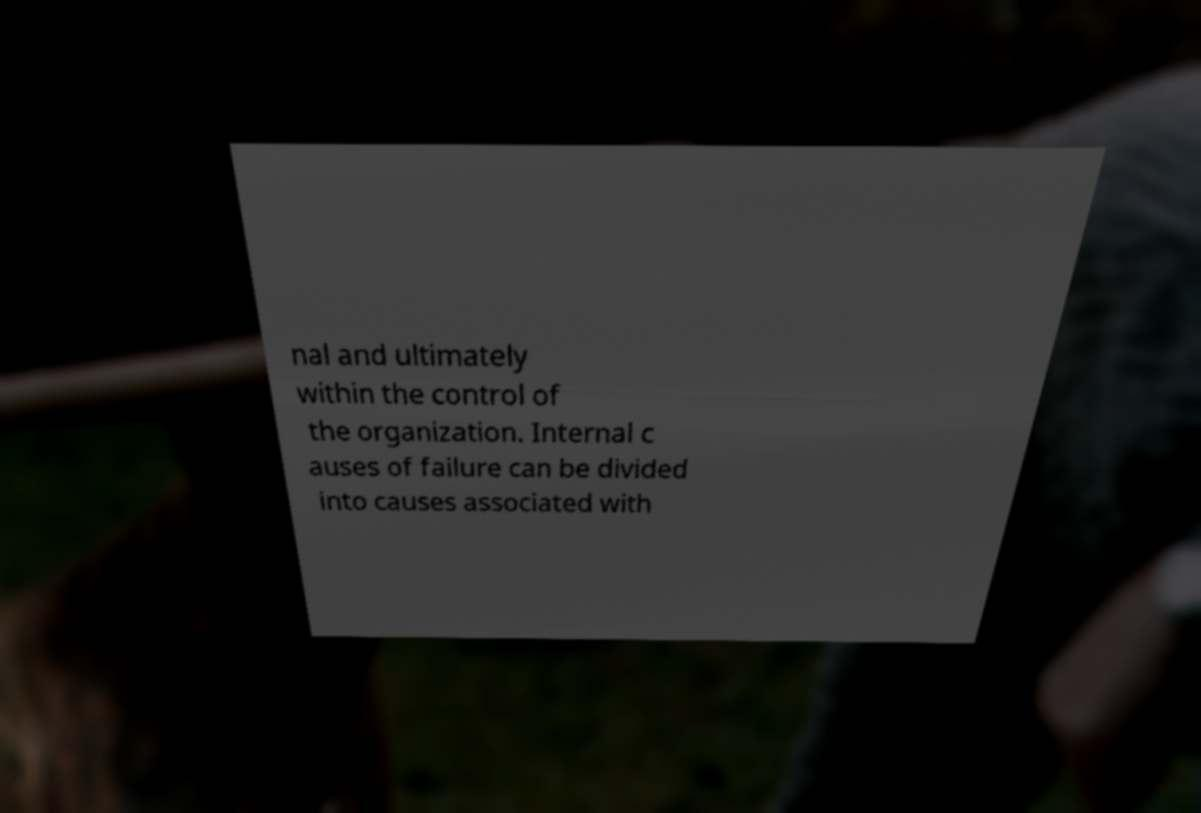For documentation purposes, I need the text within this image transcribed. Could you provide that? nal and ultimately within the control of the organization. Internal c auses of failure can be divided into causes associated with 